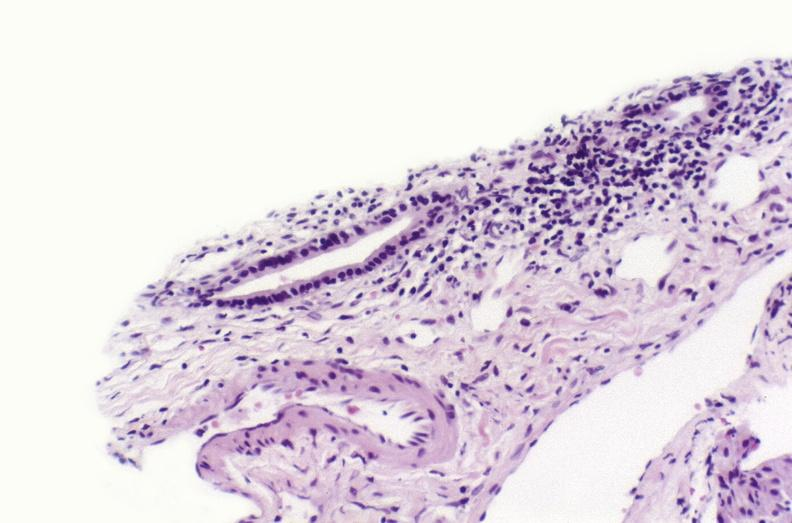s liver present?
Answer the question using a single word or phrase. Yes 